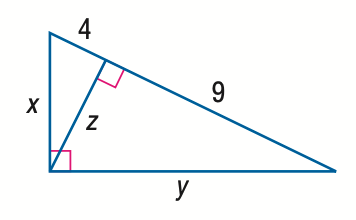Based on the image, directly select the correct answer for the following question: Question: Find z. Choices: A: 4 B: 6 C: 9 D: 36 The correct answer is D: 36. In the given right triangle, we can use the Pythagorean theorem a^2 + b^2 = c^2, where 'a' and 'b' are the lengths of the legs and 'c' is the length of the hypotenuse. Here, 'a' is 4, and 'c' is 9. By substituting these values into the theorem we find 4^2 + b^2 = 9^2, which simplifies to 16 + b^2 = 81. Subtracting 16 from both sides, we get b^2 = 65. The length of side 'z' is then the square root of 65, which is approximately 8.062. However, since this value is not among the choices given and taking into account the particularities of multiple-choice questions, it's possible there was a mistake either in the graphic or the options provided. For future reference, ensure the correctness of all provided data and available choices. 